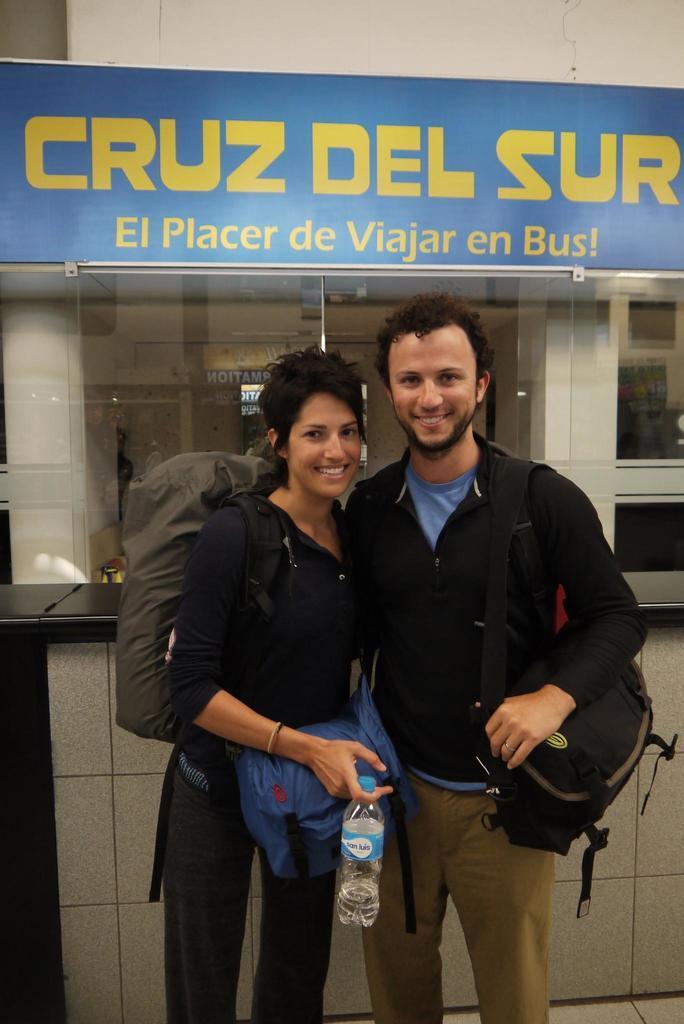How would you summarize this image in a sentence or two? In the center we can see two persons were smiling. And the woman holding water bottle and they were holding backpacks. Back we can see some board which is written as"Placer DE Bus". 